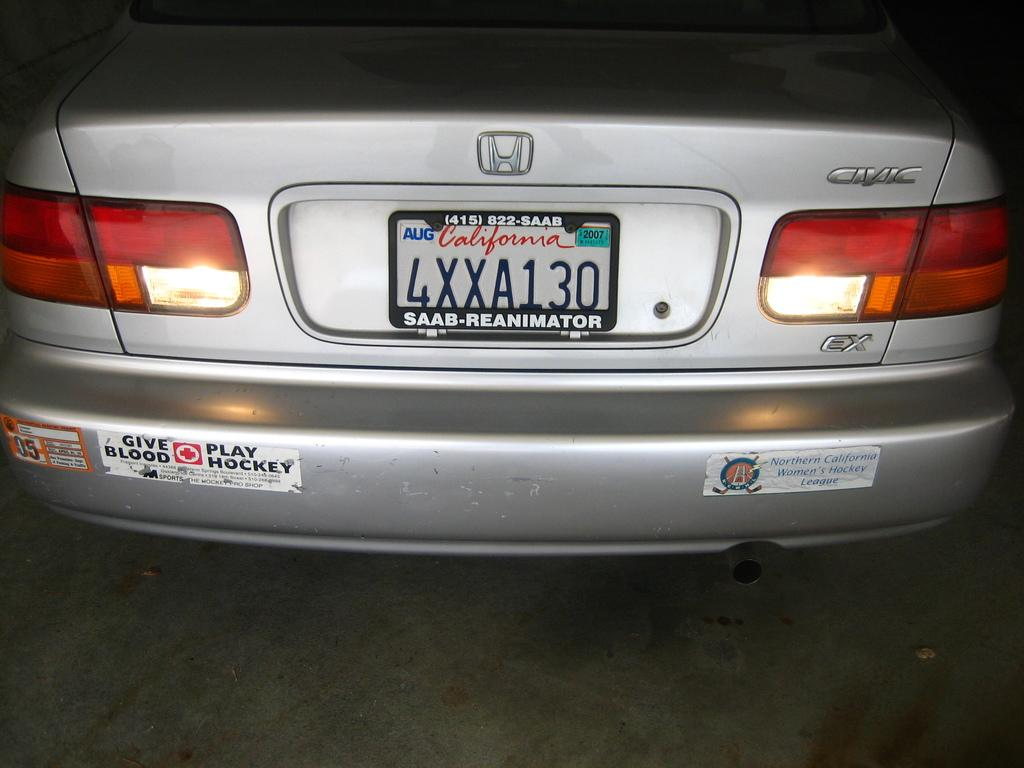What is the main subject of the image? The main subject of the image is a vehicle. What feature of the vehicle is mentioned in the facts? The vehicle has a registration number plate. What additional detail can be observed about the registration number plate? There is text written on the registration number plate. What type of harmony can be heard coming from the background of the image? There is no audible sound or music in the image, so it is not possible to determine if any harmony is present. 